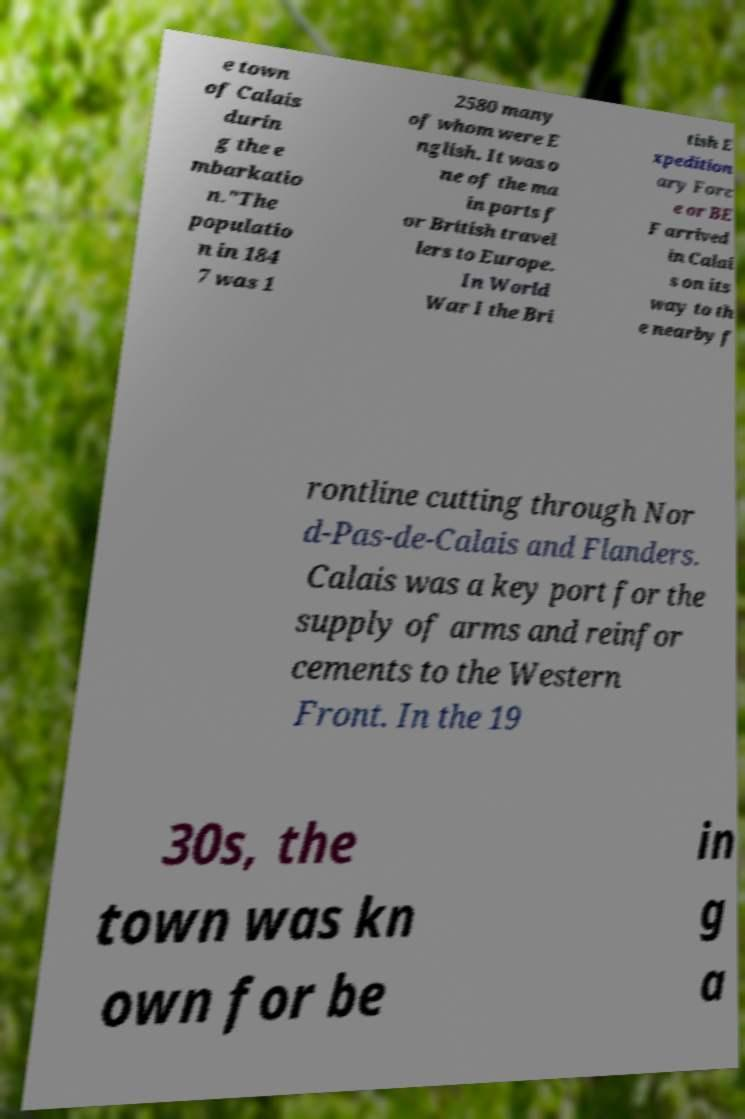Could you extract and type out the text from this image? e town of Calais durin g the e mbarkatio n."The populatio n in 184 7 was 1 2580 many of whom were E nglish. It was o ne of the ma in ports f or British travel lers to Europe. In World War I the Bri tish E xpedition ary Forc e or BE F arrived in Calai s on its way to th e nearby f rontline cutting through Nor d-Pas-de-Calais and Flanders. Calais was a key port for the supply of arms and reinfor cements to the Western Front. In the 19 30s, the town was kn own for be in g a 